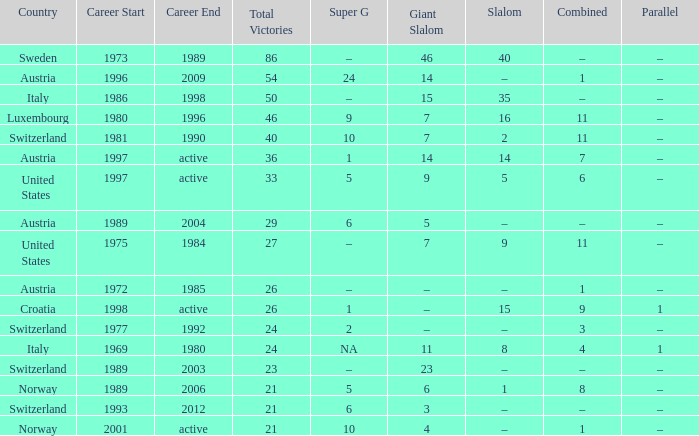Which super g athlete had a career spanning from 1980 to 1996? 9.0. 